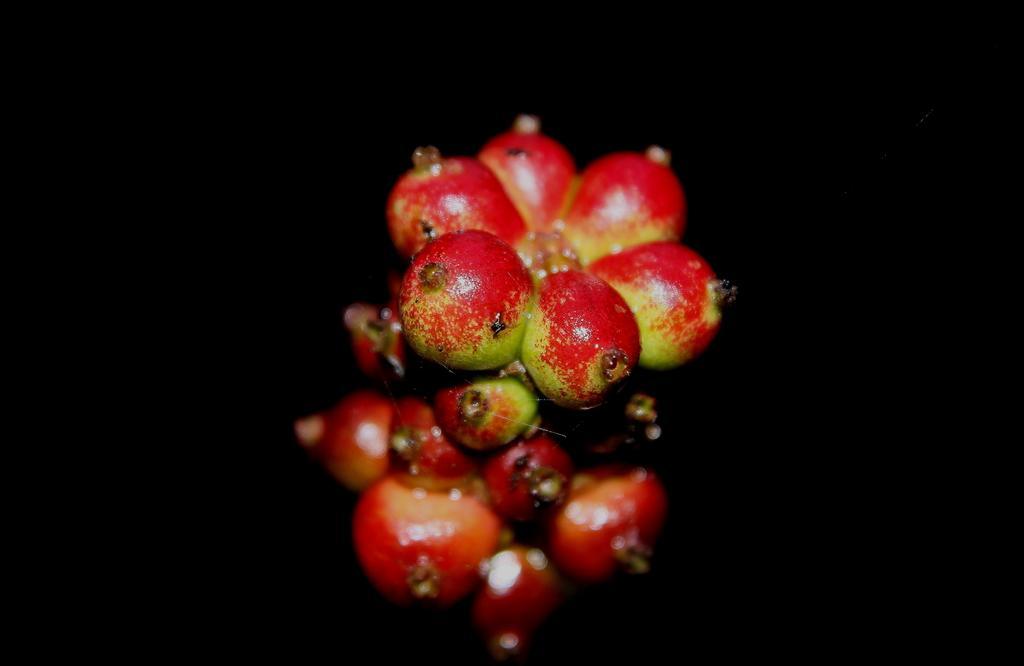Describe this image in one or two sentences. In this image there are a bunch of fruits, the background of the image is dark. 